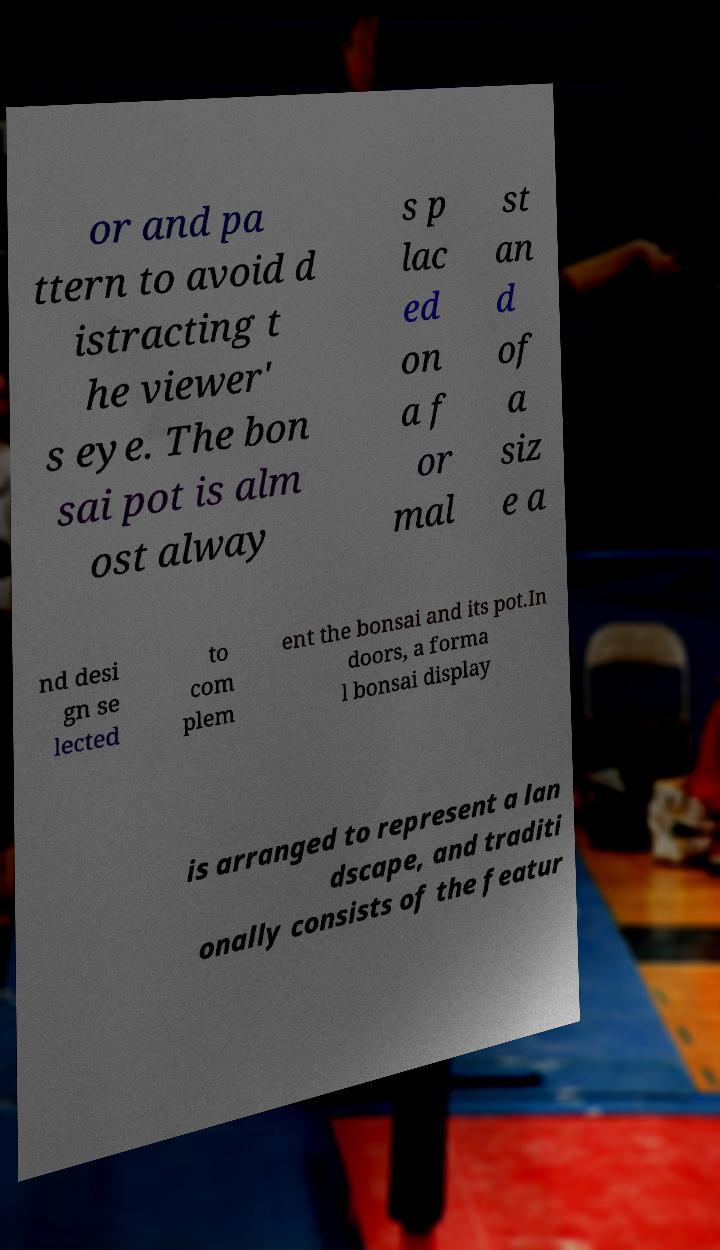What messages or text are displayed in this image? I need them in a readable, typed format. or and pa ttern to avoid d istracting t he viewer' s eye. The bon sai pot is alm ost alway s p lac ed on a f or mal st an d of a siz e a nd desi gn se lected to com plem ent the bonsai and its pot.In doors, a forma l bonsai display is arranged to represent a lan dscape, and traditi onally consists of the featur 